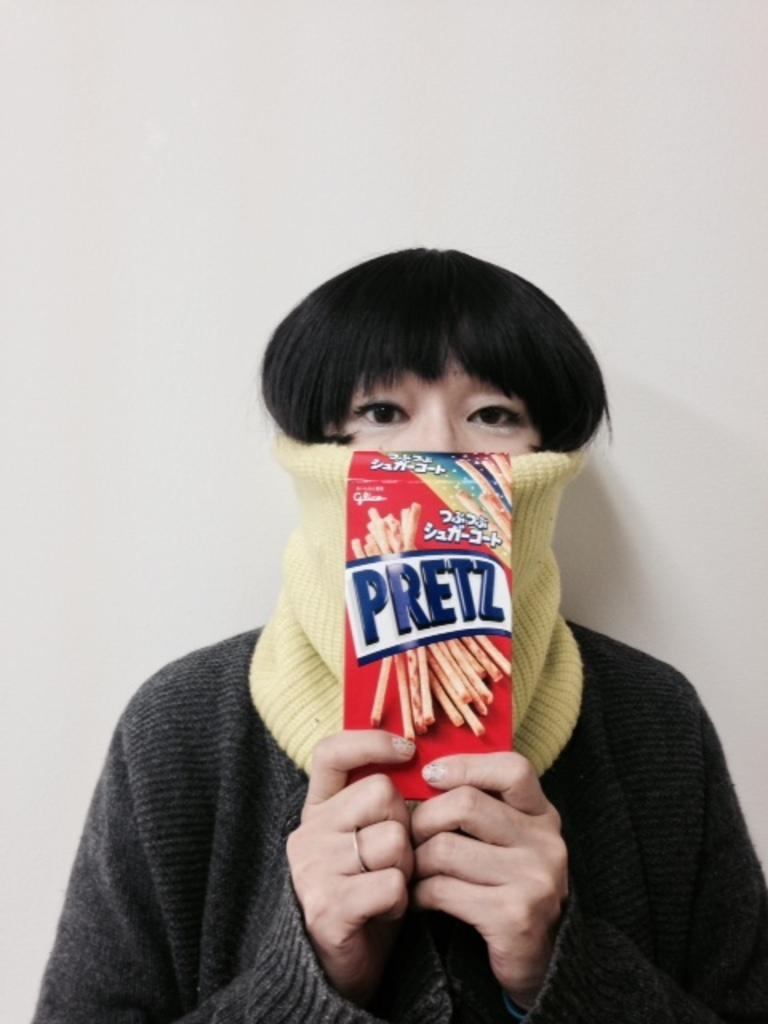What is the color of the background in the image? The background of the image is gray. Can you describe the person in the image? There is a person in the image, and they are wearing a face mask. What else can be seen in the image besides the person? There is a paper with text in the image. How many tomatoes are on the person's face in the image? There are no tomatoes present on the person's face in the image. What type of bead is being used as a decoration on the paper in the image? There is no bead present on the paper in the image. 